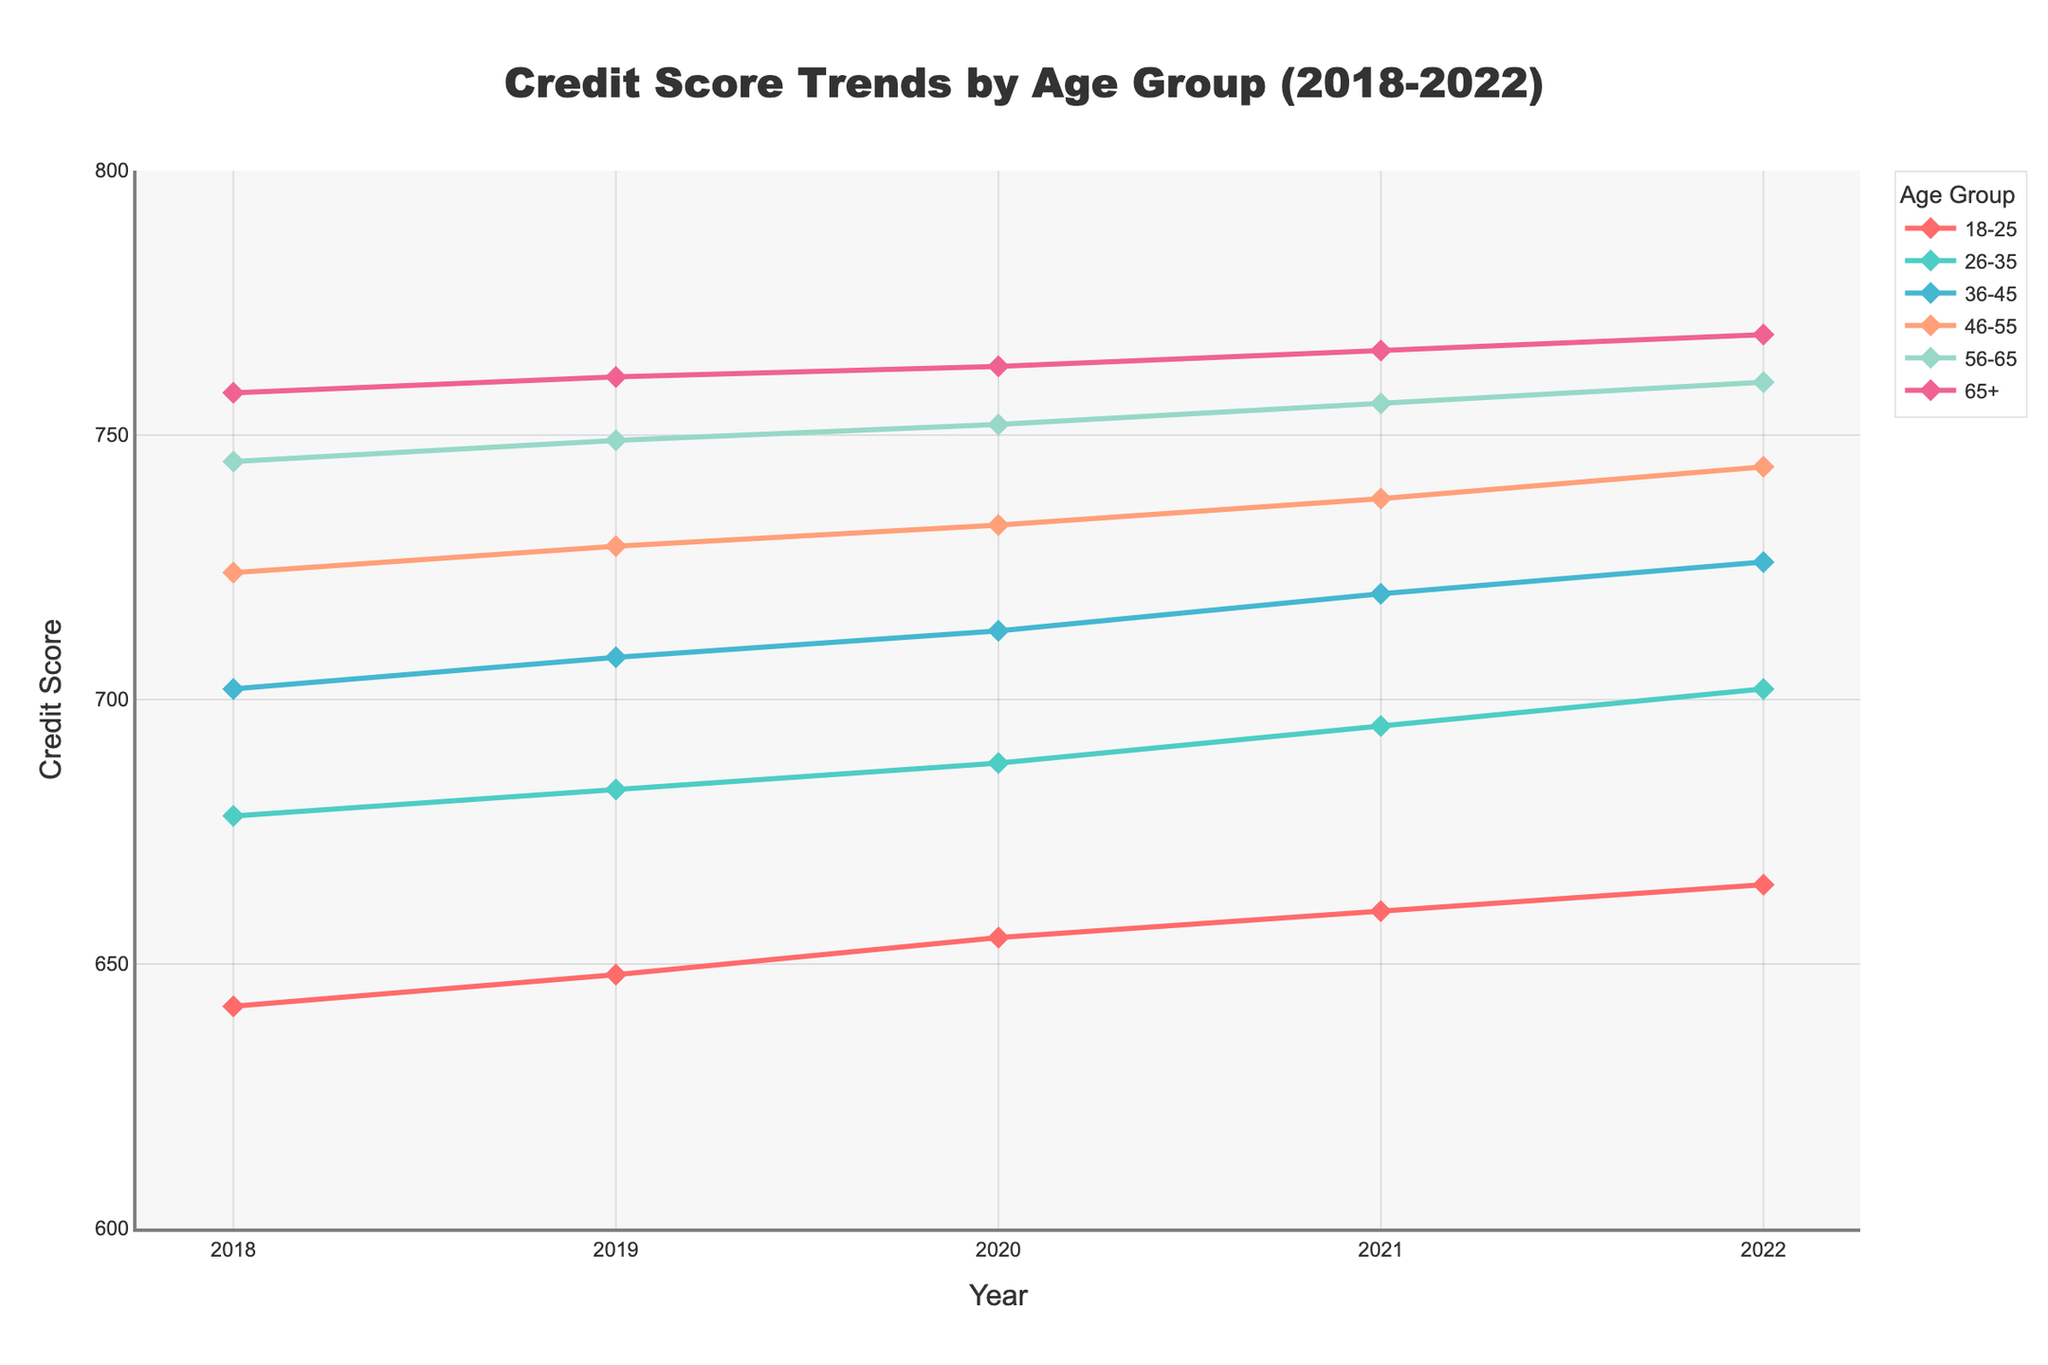Which age group has the highest credit score in 2022? Look at the values for the year 2022; the age group 65+ has the highest credit score at 769.
Answer: 65+ How did the credit score for the 18-25 age group change from 2018 to 2022? Subtract the 2018 value (642) from the 2022 value (665). The change is 665 - 642 = 23.
Answer: Increased by 23 Among the age groups, which one had the smallest increase in credit score from 2018 to 2022? For each age group, calculate the difference between 2022 and 2018 values. The smallest increase is 11 for the 65+ age group (769 - 758).
Answer: 65+ Which age group showed the most significant improvement in their credit score from 2018 to 2022? Calculate the increase for each age group. The 26-35 group improved the most with an increase of 24 (702 - 678).
Answer: 26-35 Compare the credit scores of the 36-45 and the 46-55 age groups in 2021. Which group had a higher value? Look at the values for the year 2021: the 36-45 age group has a score of 720, while the 46-55 age group has 738. The 46-55 age group has a higher score.
Answer: 46-55 What was the average credit score for all age groups in 2020? Sum the credit scores for all age groups in 2020 (655 + 688 + 713 + 733 + 752 + 763 = 4304). Then divide by the number of age groups (6): 4304 / 6 = 717.33.
Answer: 717.33 What trend do you notice in the credit scores of the 56-65 age group between 2018 and 2022? The credit score for the 56-65 age group consistently increases each year, going from 745 in 2018 to 760 in 2022, indicating an upward trend.
Answer: Increasing trend Between which consecutive years did the 26-35 age group see the largest increase in credit score? Compare the yearly differences for this group: 2019-2018 (5), 2020-2019 (5), 2021-2020 (7), and 2022-2021 (7). The largest increases were in 2021 and 2022 (7 each).
Answer: 2020-2021 and 2021-2022 Which age group had a credit score closest to 700 in 2020? The value closest to 700 in 2020 is 688 (26-35), as none of the other scores are closer.
Answer: 26-35 